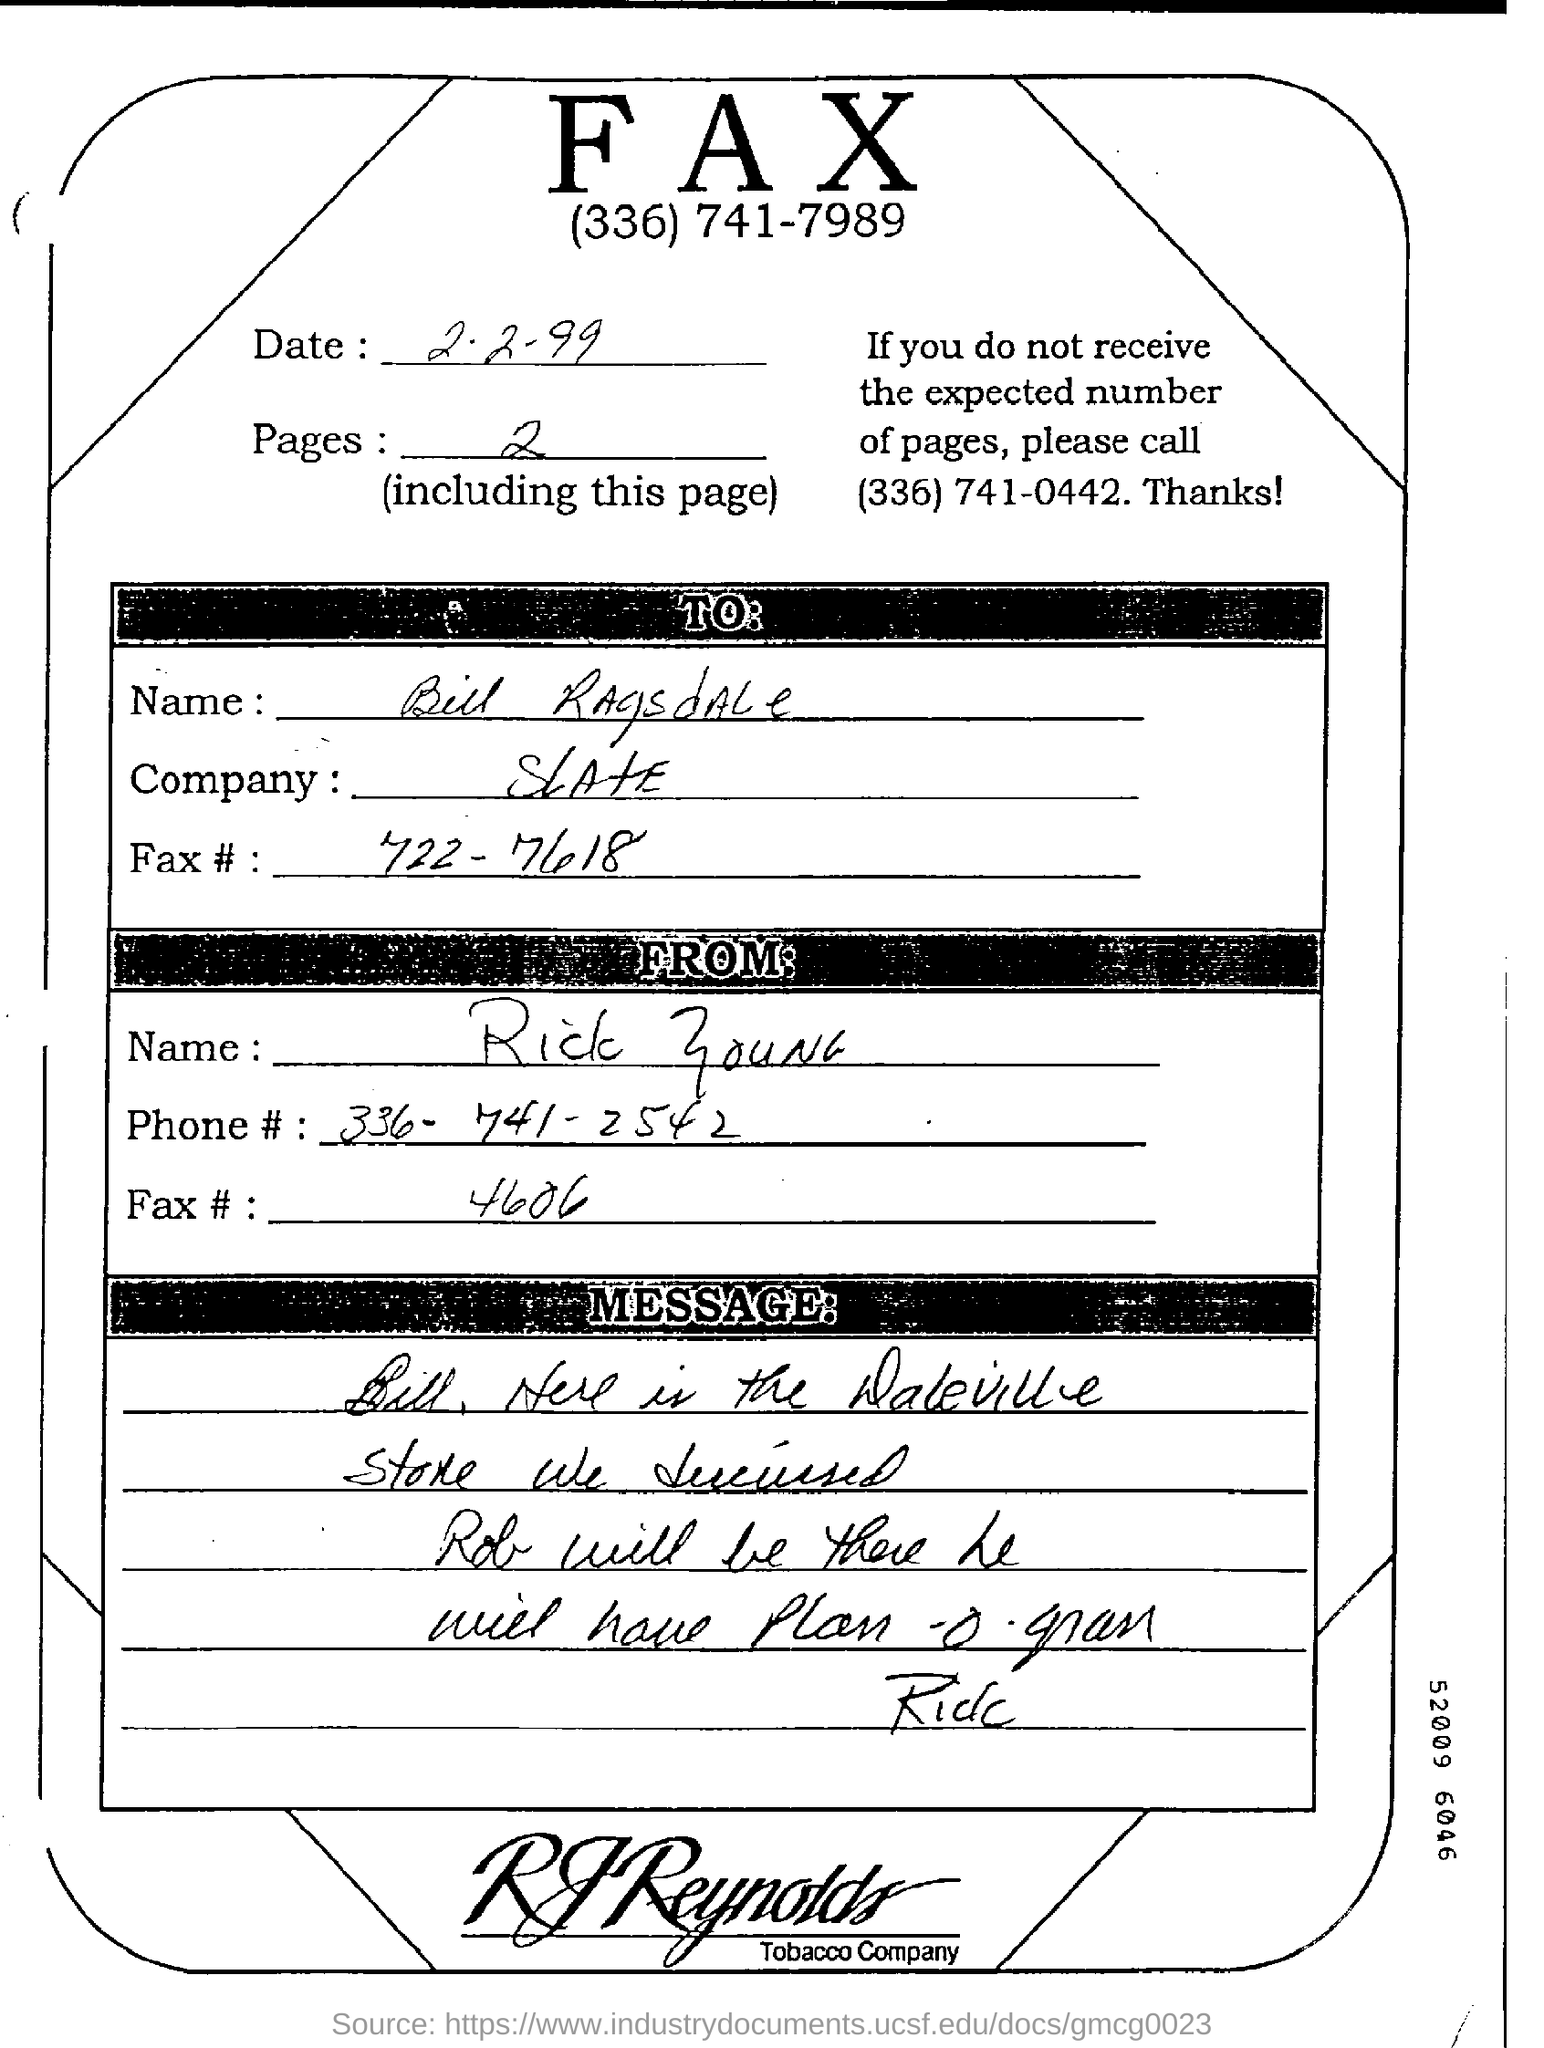Date of the fax ?
Ensure brevity in your answer.  2.2-99. What is the number of pages ?
Offer a terse response. 2. What is the fax# of Rick?
Your response must be concise. 4606. Name the person to send fax?
Give a very brief answer. Bill ragsdale. Phone number of rick young?
Keep it short and to the point. 336-741-2542. Including this page how many pages are there ?
Ensure brevity in your answer.  2. 